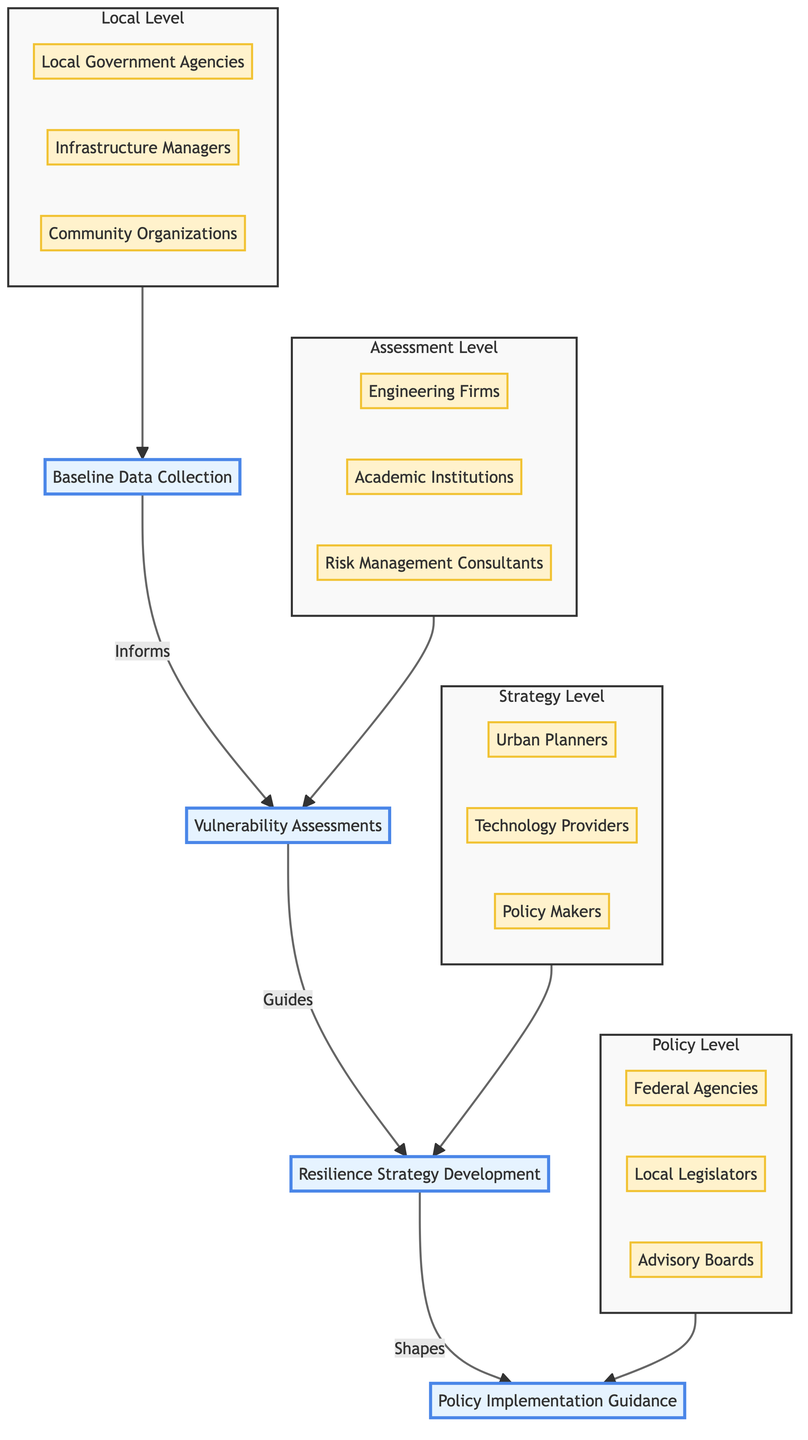What is the first step in the evaluation process? The diagram represents a flowchart where the first step at the bottom is labeled "Baseline Data Collection." This indicates the starting point of the process.
Answer: Baseline Data Collection How many distinct steps are there in the Infrastructure Resilience Evaluation Process? By counting the steps listed vertically in the diagram from bottom to top, we see there are four distinct steps: Baseline Data Collection, Vulnerability Assessments, Resilience Strategy Development, and Policy Implementation Guidance.
Answer: Four Who is involved in Baseline Data Collection? The diagram specifies three entities involved in this step: Local Government Agencies, Infrastructure Managers, and Community Organizations. By identifying the entities listed under the "Local Level" section, we find this specific information.
Answer: Local Government Agencies, Infrastructure Managers, Community Organizations Which step informs the Vulnerability Assessments? The diagram shows an arrow pointing from "Baseline Data Collection" to "Vulnerability Assessments," indicating that the first step provides necessary information for this next stage in the sequence.
Answer: Baseline Data Collection What do Resilience Strategy Development and Policy Implementation Guidance have in common? Both steps involve policy makers as one of the entities listed separately under their corresponding sections in the diagram, indicating a consistent role across two different stages of the process.
Answer: Policy Makers What type of assessments occur after Baseline Data Collection? The next step in the diagram, as depicted by the arrows connecting the nodes, is "Vulnerability Assessments." This step directly follows the initial data collection.
Answer: Vulnerability Assessments Which entities are involved in the Resilience Strategy Development? In the diagram, three entities are designated in the "Strategy Level" enclosure, which are Urban Planners, Technology Providers, and Policy Makers. This leads us directly to identifying the involved parties.
Answer: Urban Planners, Technology Providers, Policy Makers What guides the Policy Implementation Guidance? The arrow in the diagram shows that "Resilience Strategy Development" shapes and guides this final step, illustrating the flow and connection between the two.
Answer: Resilience Strategy Development Identify the last step in the evaluation process. Observing the flowchart from bottom to top, the final step at the top is labeled "Policy Implementation Guidance," which signifies the conclusion of the process.
Answer: Policy Implementation Guidance 